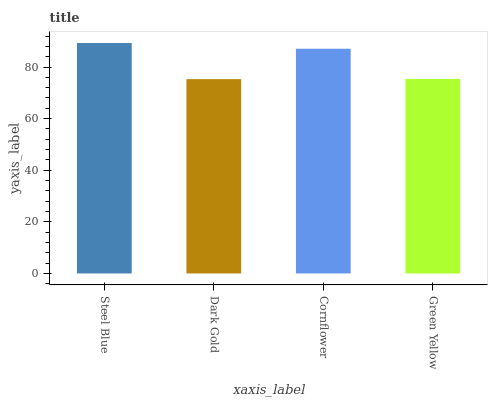Is Dark Gold the minimum?
Answer yes or no. Yes. Is Steel Blue the maximum?
Answer yes or no. Yes. Is Cornflower the minimum?
Answer yes or no. No. Is Cornflower the maximum?
Answer yes or no. No. Is Cornflower greater than Dark Gold?
Answer yes or no. Yes. Is Dark Gold less than Cornflower?
Answer yes or no. Yes. Is Dark Gold greater than Cornflower?
Answer yes or no. No. Is Cornflower less than Dark Gold?
Answer yes or no. No. Is Cornflower the high median?
Answer yes or no. Yes. Is Green Yellow the low median?
Answer yes or no. Yes. Is Green Yellow the high median?
Answer yes or no. No. Is Steel Blue the low median?
Answer yes or no. No. 